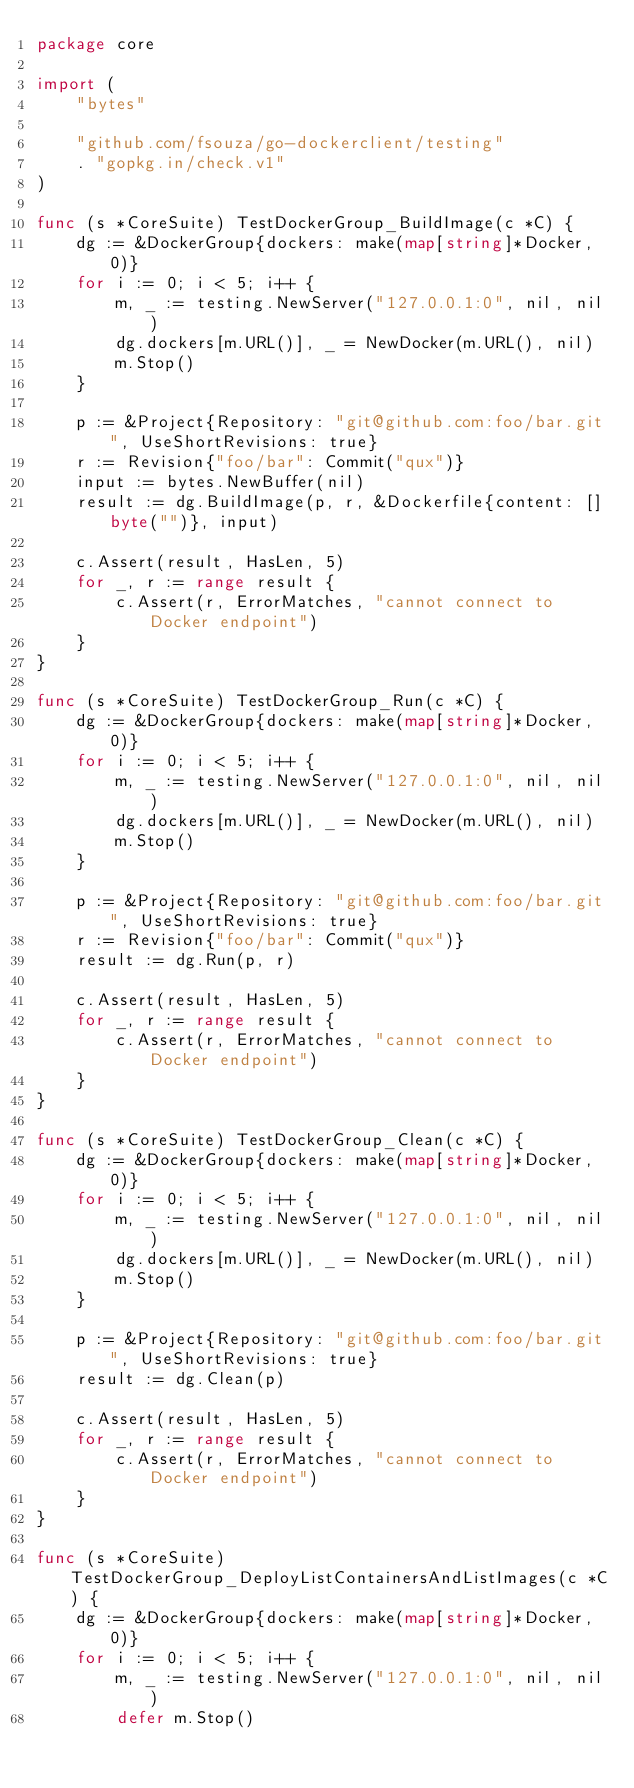<code> <loc_0><loc_0><loc_500><loc_500><_Go_>package core

import (
	"bytes"

	"github.com/fsouza/go-dockerclient/testing"
	. "gopkg.in/check.v1"
)

func (s *CoreSuite) TestDockerGroup_BuildImage(c *C) {
	dg := &DockerGroup{dockers: make(map[string]*Docker, 0)}
	for i := 0; i < 5; i++ {
		m, _ := testing.NewServer("127.0.0.1:0", nil, nil)
		dg.dockers[m.URL()], _ = NewDocker(m.URL(), nil)
		m.Stop()
	}

	p := &Project{Repository: "git@github.com:foo/bar.git", UseShortRevisions: true}
	r := Revision{"foo/bar": Commit("qux")}
	input := bytes.NewBuffer(nil)
	result := dg.BuildImage(p, r, &Dockerfile{content: []byte("")}, input)

	c.Assert(result, HasLen, 5)
	for _, r := range result {
		c.Assert(r, ErrorMatches, "cannot connect to Docker endpoint")
	}
}

func (s *CoreSuite) TestDockerGroup_Run(c *C) {
	dg := &DockerGroup{dockers: make(map[string]*Docker, 0)}
	for i := 0; i < 5; i++ {
		m, _ := testing.NewServer("127.0.0.1:0", nil, nil)
		dg.dockers[m.URL()], _ = NewDocker(m.URL(), nil)
		m.Stop()
	}

	p := &Project{Repository: "git@github.com:foo/bar.git", UseShortRevisions: true}
	r := Revision{"foo/bar": Commit("qux")}
	result := dg.Run(p, r)

	c.Assert(result, HasLen, 5)
	for _, r := range result {
		c.Assert(r, ErrorMatches, "cannot connect to Docker endpoint")
	}
}

func (s *CoreSuite) TestDockerGroup_Clean(c *C) {
	dg := &DockerGroup{dockers: make(map[string]*Docker, 0)}
	for i := 0; i < 5; i++ {
		m, _ := testing.NewServer("127.0.0.1:0", nil, nil)
		dg.dockers[m.URL()], _ = NewDocker(m.URL(), nil)
		m.Stop()
	}

	p := &Project{Repository: "git@github.com:foo/bar.git", UseShortRevisions: true}
	result := dg.Clean(p)

	c.Assert(result, HasLen, 5)
	for _, r := range result {
		c.Assert(r, ErrorMatches, "cannot connect to Docker endpoint")
	}
}

func (s *CoreSuite) TestDockerGroup_DeployListContainersAndListImages(c *C) {
	dg := &DockerGroup{dockers: make(map[string]*Docker, 0)}
	for i := 0; i < 5; i++ {
		m, _ := testing.NewServer("127.0.0.1:0", nil, nil)
		defer m.Stop()</code> 